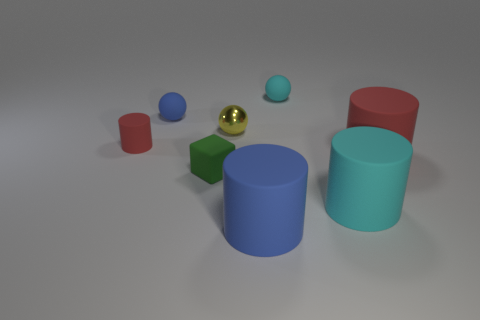What material is the yellow object?
Your answer should be compact. Metal. There is a large cylinder that is the same color as the small matte cylinder; what material is it?
Keep it short and to the point. Rubber. Does the green matte object in front of the yellow thing have the same shape as the small blue thing?
Your answer should be compact. No. What number of objects are either red matte cylinders or small cyan matte spheres?
Give a very brief answer. 3. Do the blue thing left of the small block and the yellow ball have the same material?
Provide a short and direct response. No. The green matte cube has what size?
Give a very brief answer. Small. What shape is the large matte object that is the same color as the small cylinder?
Your response must be concise. Cylinder. How many blocks are either tiny red objects or small blue matte things?
Provide a succinct answer. 0. Is the number of tiny matte spheres that are left of the big red object the same as the number of large matte objects in front of the small green thing?
Your answer should be very brief. Yes. There is a cyan rubber object that is the same shape as the small metal thing; what size is it?
Your answer should be compact. Small. 